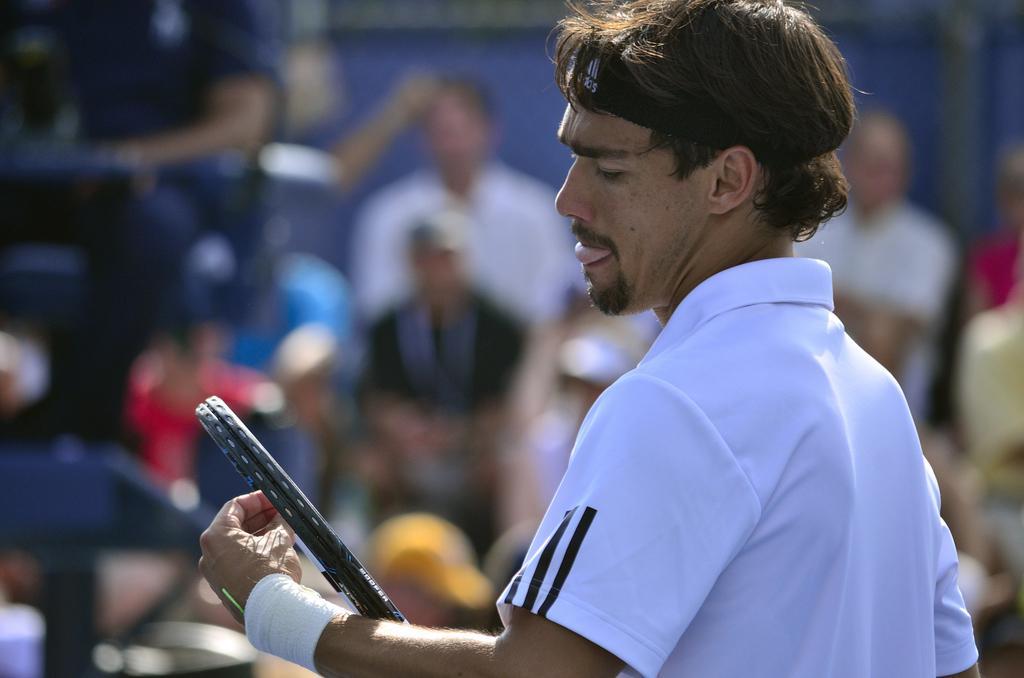Can you describe this image briefly? In this image we can see a person wearing white color dress, wrist band holding tennis racket in his hands and in the background of the image there are some persons sitting. 